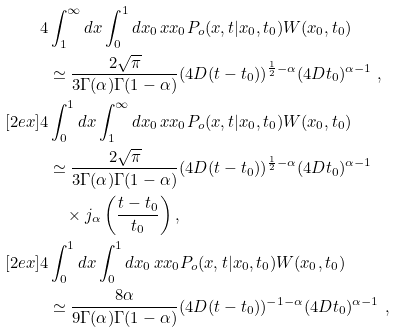Convert formula to latex. <formula><loc_0><loc_0><loc_500><loc_500>4 & \int _ { 1 } ^ { \infty } d x \int _ { 0 } ^ { 1 } d x _ { 0 } \, x x _ { 0 } P _ { o } ( x , t | x _ { 0 } , t _ { 0 } ) W ( x _ { 0 } , t _ { 0 } ) \\ & \simeq \frac { 2 \sqrt { \pi } } { 3 \Gamma ( \alpha ) \Gamma ( 1 - \alpha ) } ( 4 D ( t - t _ { 0 } ) ) ^ { \frac { 1 } { 2 } - \alpha } ( 4 D t _ { 0 } ) ^ { \alpha - 1 } \ , \\ [ 2 e x ] 4 & \int _ { 0 } ^ { 1 } d x \int _ { 1 } ^ { \infty } d x _ { 0 } \, x x _ { 0 } P _ { o } ( x , t | x _ { 0 } , t _ { 0 } ) W ( x _ { 0 } , t _ { 0 } ) \\ & \simeq \frac { 2 \sqrt { \pi } } { 3 \Gamma ( \alpha ) \Gamma ( 1 - \alpha ) } ( 4 D ( t - t _ { 0 } ) ) ^ { \frac { 1 } { 2 } - \alpha } ( 4 D t _ { 0 } ) ^ { \alpha - 1 } \\ & \quad \times j _ { \alpha } \left ( \frac { t - t _ { 0 } } { t _ { 0 } } \right ) , \\ [ 2 e x ] 4 & \int _ { 0 } ^ { 1 } d x \int _ { 0 } ^ { 1 } d x _ { 0 } \, x x _ { 0 } P _ { o } ( x , t | x _ { 0 } , t _ { 0 } ) W ( x _ { 0 } , t _ { 0 } ) \\ & \simeq \frac { 8 \alpha } { 9 \Gamma ( \alpha ) \Gamma ( 1 - \alpha ) } ( 4 D ( t - t _ { 0 } ) ) ^ { - 1 - \alpha } ( 4 D t _ { 0 } ) ^ { \alpha - 1 } \ ,</formula> 